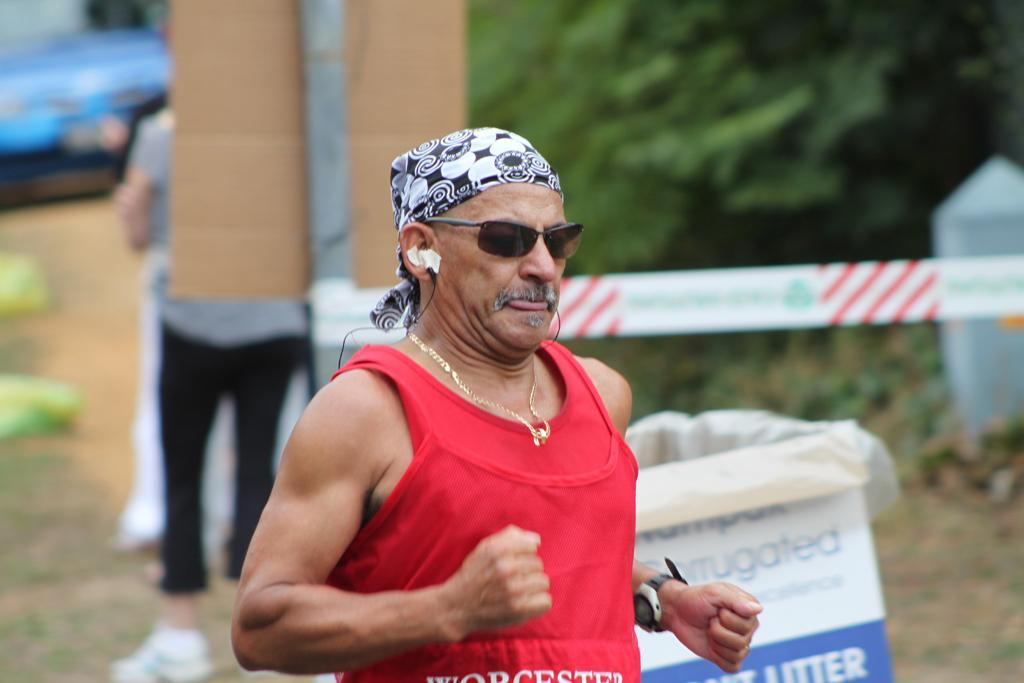In one or two sentences, can you explain what this image depicts? In this picture, we can see a man in the red t shirt is running on the path and behind the man there is another person is standing, trees and some blurred things. 